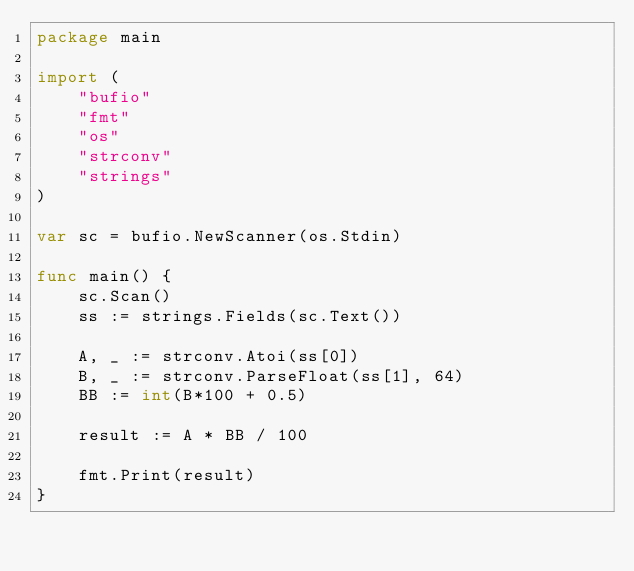<code> <loc_0><loc_0><loc_500><loc_500><_Go_>package main

import (
	"bufio"
	"fmt"
	"os"
	"strconv"
	"strings"
)

var sc = bufio.NewScanner(os.Stdin)

func main() {
	sc.Scan()
	ss := strings.Fields(sc.Text())

	A, _ := strconv.Atoi(ss[0])
	B, _ := strconv.ParseFloat(ss[1], 64)
	BB := int(B*100 + 0.5)

	result := A * BB / 100

	fmt.Print(result)
}
</code> 